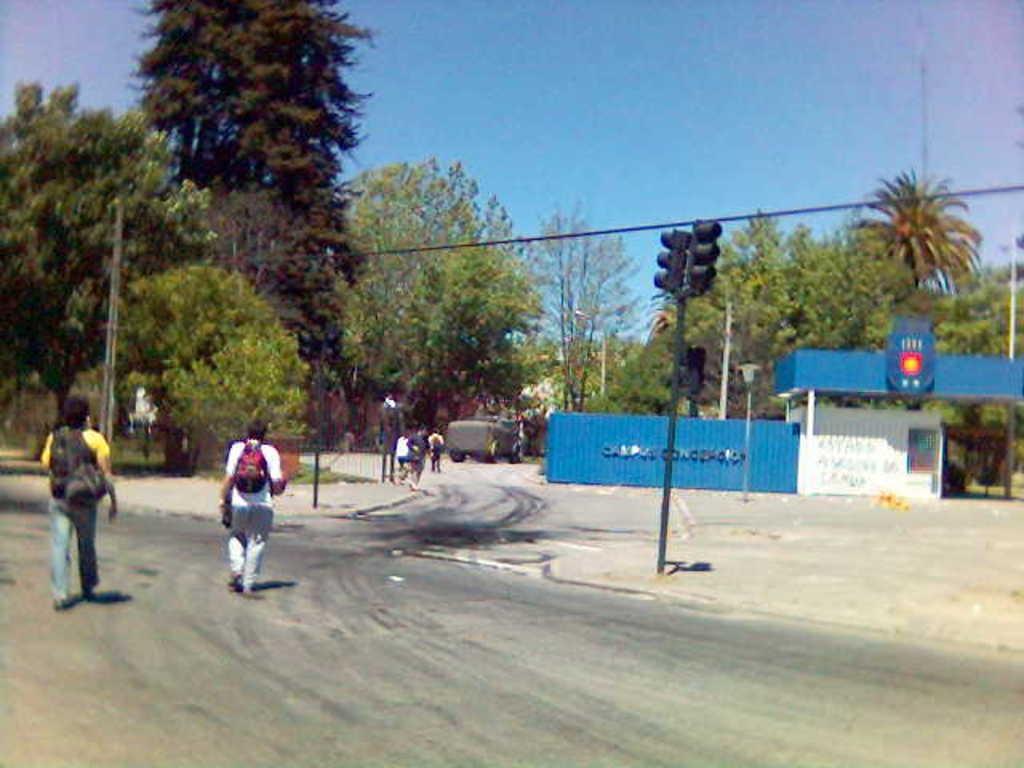Describe this image in one or two sentences. In this image we can see few people walking on the road and there is a vehicle on the road, there is a shed, few trees, traffic signal, a pole with wire and sky in the background. 